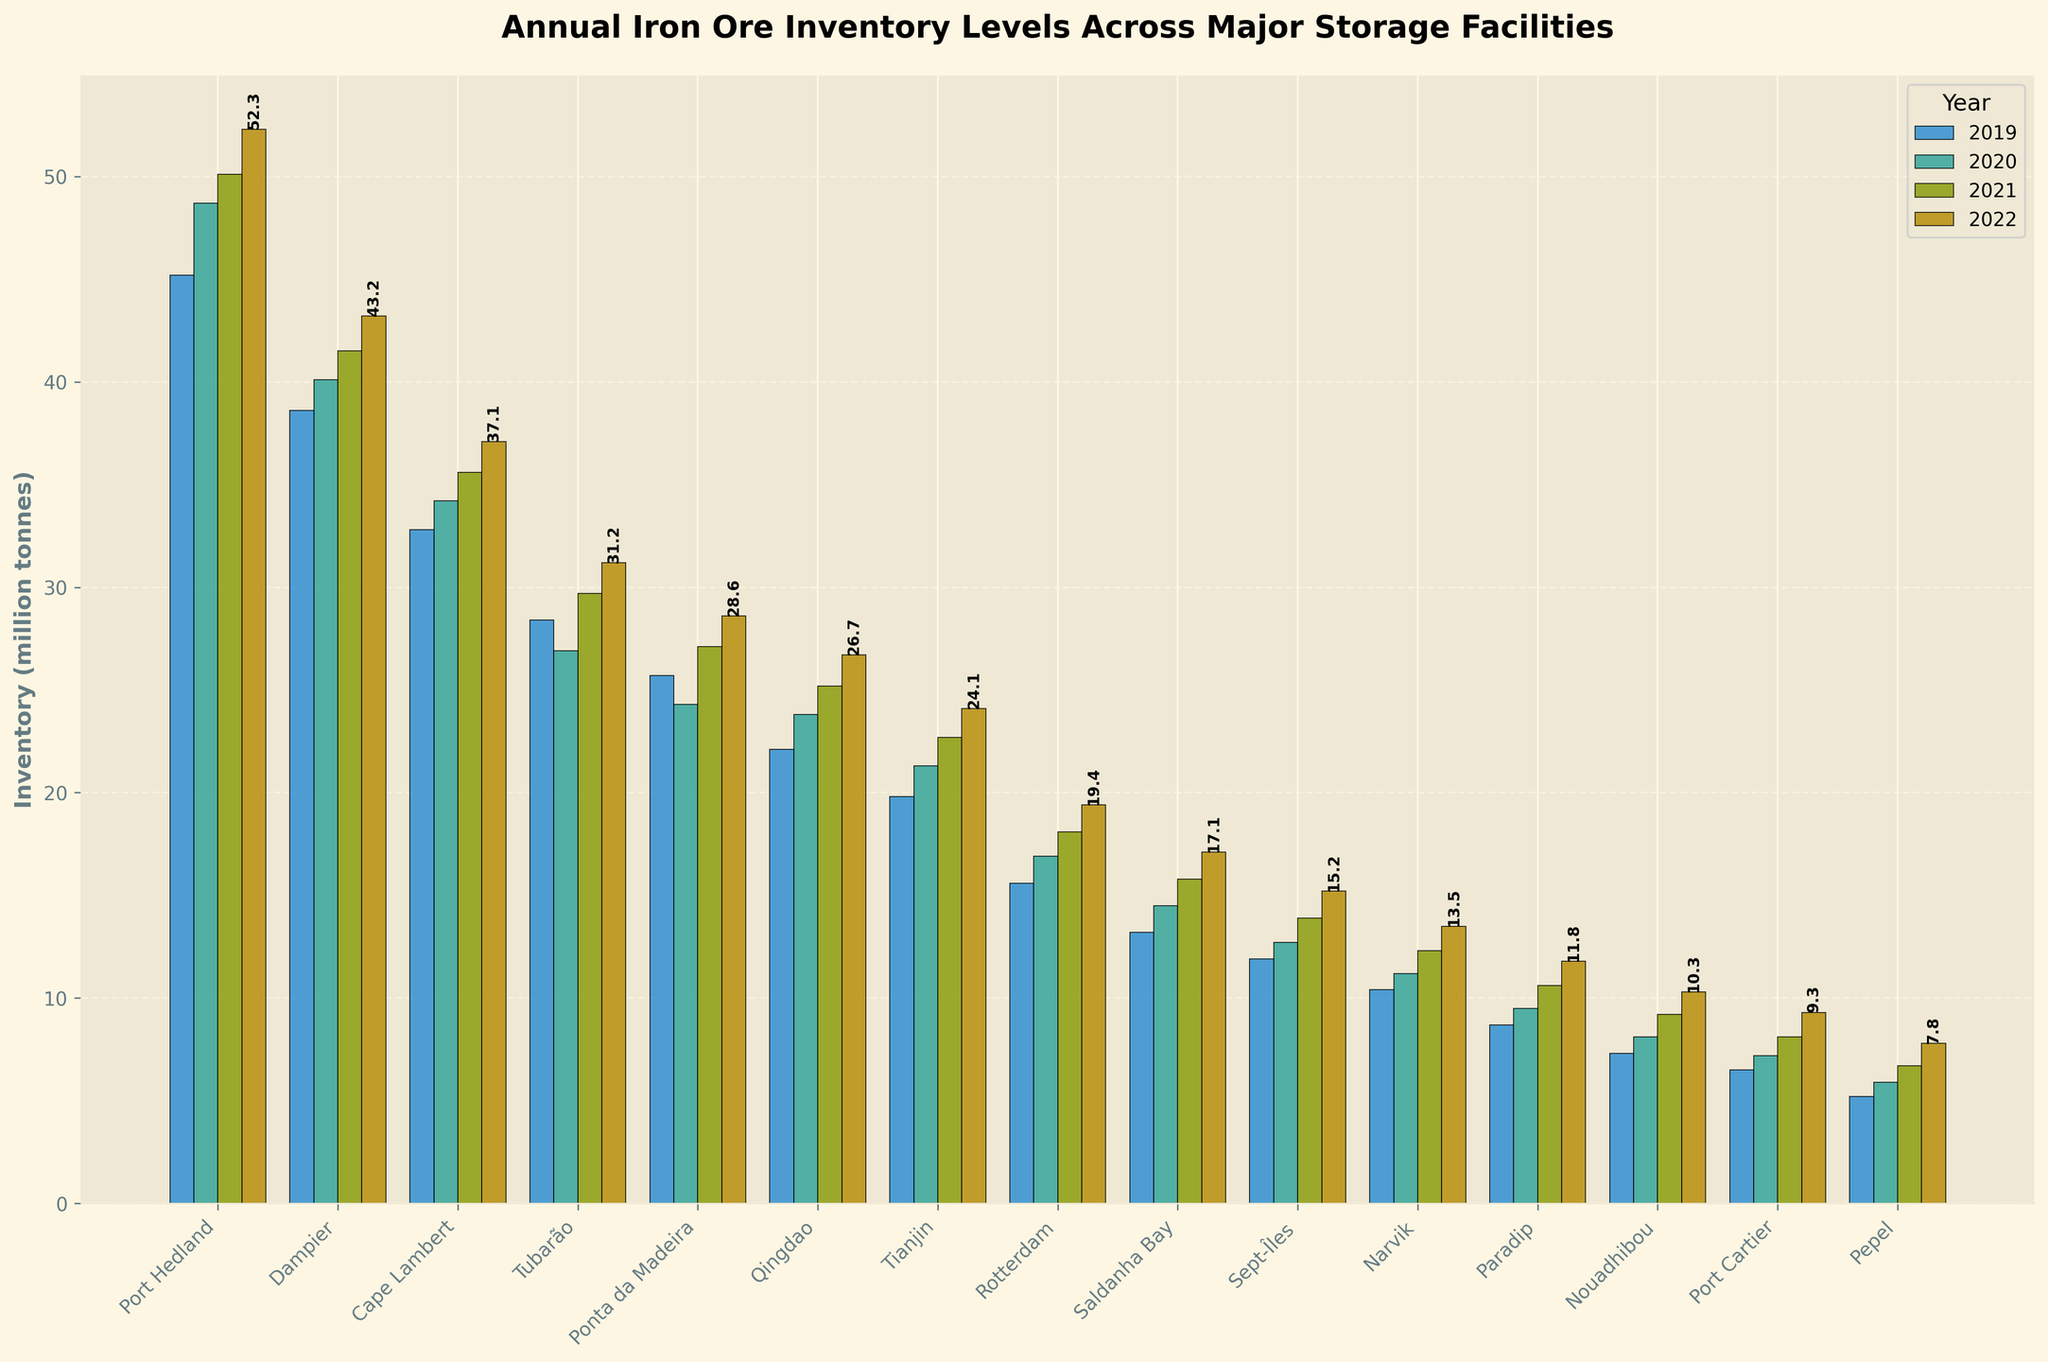What is the total iron ore inventory for Port Hedland across all years displayed? Add up the inventory for Port Hedland for the years 2019, 2020, 2021, and 2022: 45.2 + 48.7 + 50.1 + 52.3 = 196.3 million tonnes
Answer: 196.3 million tonnes Which facility had the highest inventory level in 2022? Look at the height of the bars for the year 2022 and identify the tallest one. The tallest bar corresponds to Port Hedland, Australia, with an inventory level of 52.3 million tonnes
Answer: Port Hedland What is the average iron ore inventory for Tubarão over the years shown? Calculate the average inventory for Tubarão by summing the values and dividing by the number of years: (28.4 + 26.9 + 29.7 + 31.2) / 4 = 116.2 / 4 = 29.05 million tonnes
Answer: 29.05 million tonnes Which country has the most facilities listed in the figure? Count the number of facilities for each country: Australia (3), Brazil (2), China (2), Netherlands (1), South Africa (1), Canada (2), Norway (1), India (1), Mauritania (1), Sierra Leone (1). Australia has the most facilities listed.
Answer: Australia What is the difference in 2022 inventory levels between Qingdao and Ponta da Madeira? Subtract the 2022 inventory of Ponta da Madeira from that of Qingdao: 26.7 - 28.6 = -1.9 million tonnes
Answer: -1.9 million tonnes What is the trend of iron ore inventory levels for Sept-Îles from 2019 to 2022? Look at the bars for Sept-Îles, Canada, across all years. The inventory levels are consistently increasing: 11.9, 12.7, 13.9, 15.2 million tonnes. This shows a rising trend.
Answer: Increasing How does the 2021 inventory of Rotterdam compare to the 2021 inventory of Tianjin? Look at the height of the bars for both Rotterdam and Tianjin for 2021. Rotterdam's inventory in 2021 is 18.1 million tonnes, while Tianjin's inventory is 22.7 million tonnes. Tianjin's inventory is higher.
Answer: Tianjin has higher inventory What is the sum of inventories for all Chinese facilities in 2020? Add the 2020 inventories for Qingdao and Tianjin: 23.8 + 21.3 = 45.1 million tonnes
Answer: 45.1 million tonnes What is the visual difference in bar heights between Narvik and Nouadhibou in 2021? Compare the heights of the bars for Narvik and Nouadhibou for 2021. Narvik has an inventory of 12.3 million tonnes, and Nouadhibou has 9.2 million tonnes. Narvik's bar is taller.
Answer: Narvik's bar is taller Which facility showed an increase of more than 1 million tonnes in inventory from 2019 to 2020? Calculate the difference between 2020 and 2019 inventories for all facilities and identify any differences greater than 1 million tonnes: Port Hedland (3.5), Dampier (1.5), Cape Lambert (1.4), Qingdao (1.7), Tianjin (1.5), Rotterdam (1.3), Saldanha Bay (1.3). All these facilities showed an increase of more than 1 million tonnes.
Answer: Multiple facilities (Port Hedland, Dampier, Cape Lambert, Qingdao, Tianjin, Rotterdam, Saldanha Bay) 